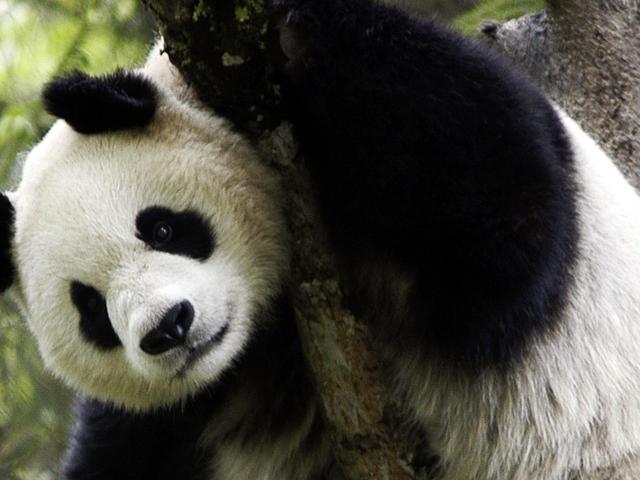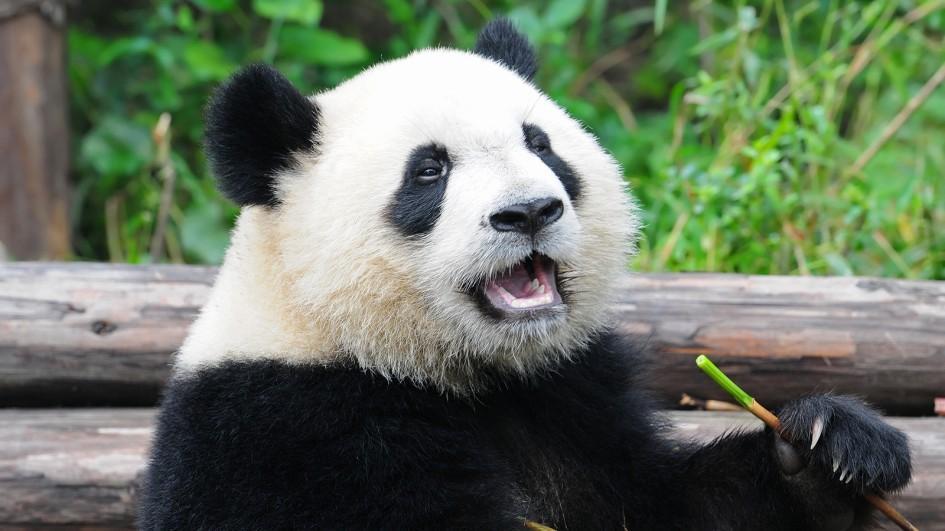The first image is the image on the left, the second image is the image on the right. For the images displayed, is the sentence "An image shows exactly one panda, and it has an opened mouth." factually correct? Answer yes or no. Yes. The first image is the image on the left, the second image is the image on the right. Analyze the images presented: Is the assertion "A single panda is in one image with its mouth open, showing the pink interior and some teeth." valid? Answer yes or no. Yes. 